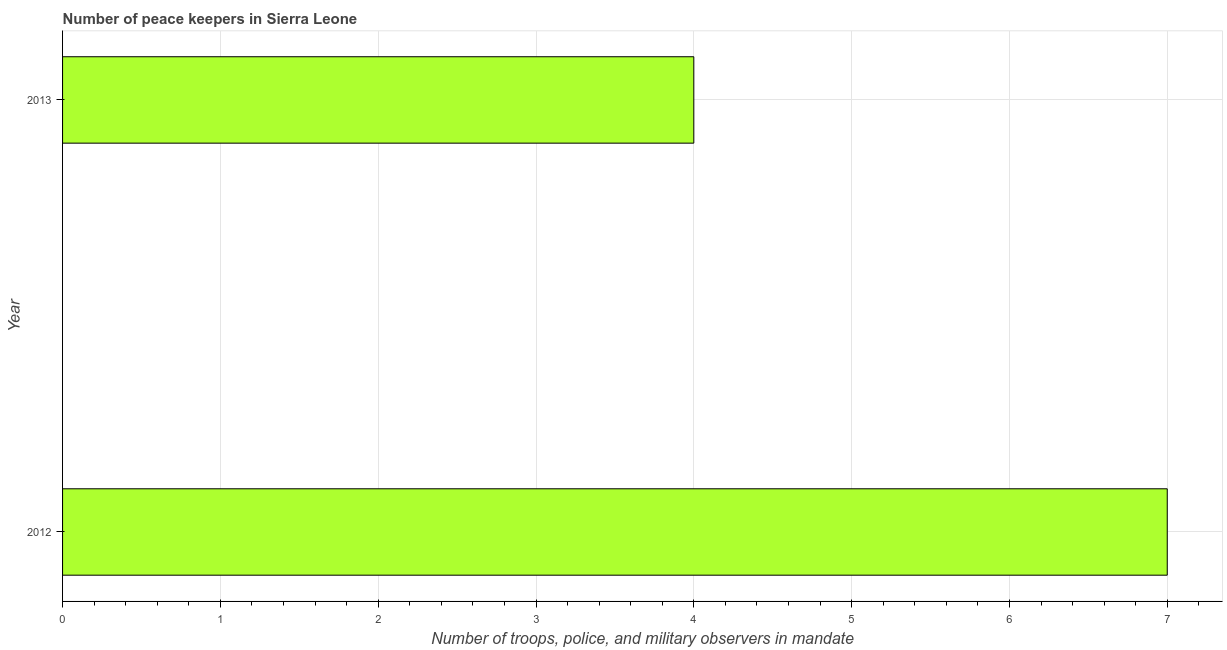Does the graph contain grids?
Offer a terse response. Yes. What is the title of the graph?
Keep it short and to the point. Number of peace keepers in Sierra Leone. What is the label or title of the X-axis?
Give a very brief answer. Number of troops, police, and military observers in mandate. What is the number of peace keepers in 2013?
Offer a very short reply. 4. What is the median number of peace keepers?
Give a very brief answer. 5.5. What is the ratio of the number of peace keepers in 2012 to that in 2013?
Give a very brief answer. 1.75. Is the number of peace keepers in 2012 less than that in 2013?
Offer a terse response. No. Are all the bars in the graph horizontal?
Provide a succinct answer. Yes. What is the Number of troops, police, and military observers in mandate of 2013?
Offer a terse response. 4. What is the difference between the Number of troops, police, and military observers in mandate in 2012 and 2013?
Give a very brief answer. 3. 